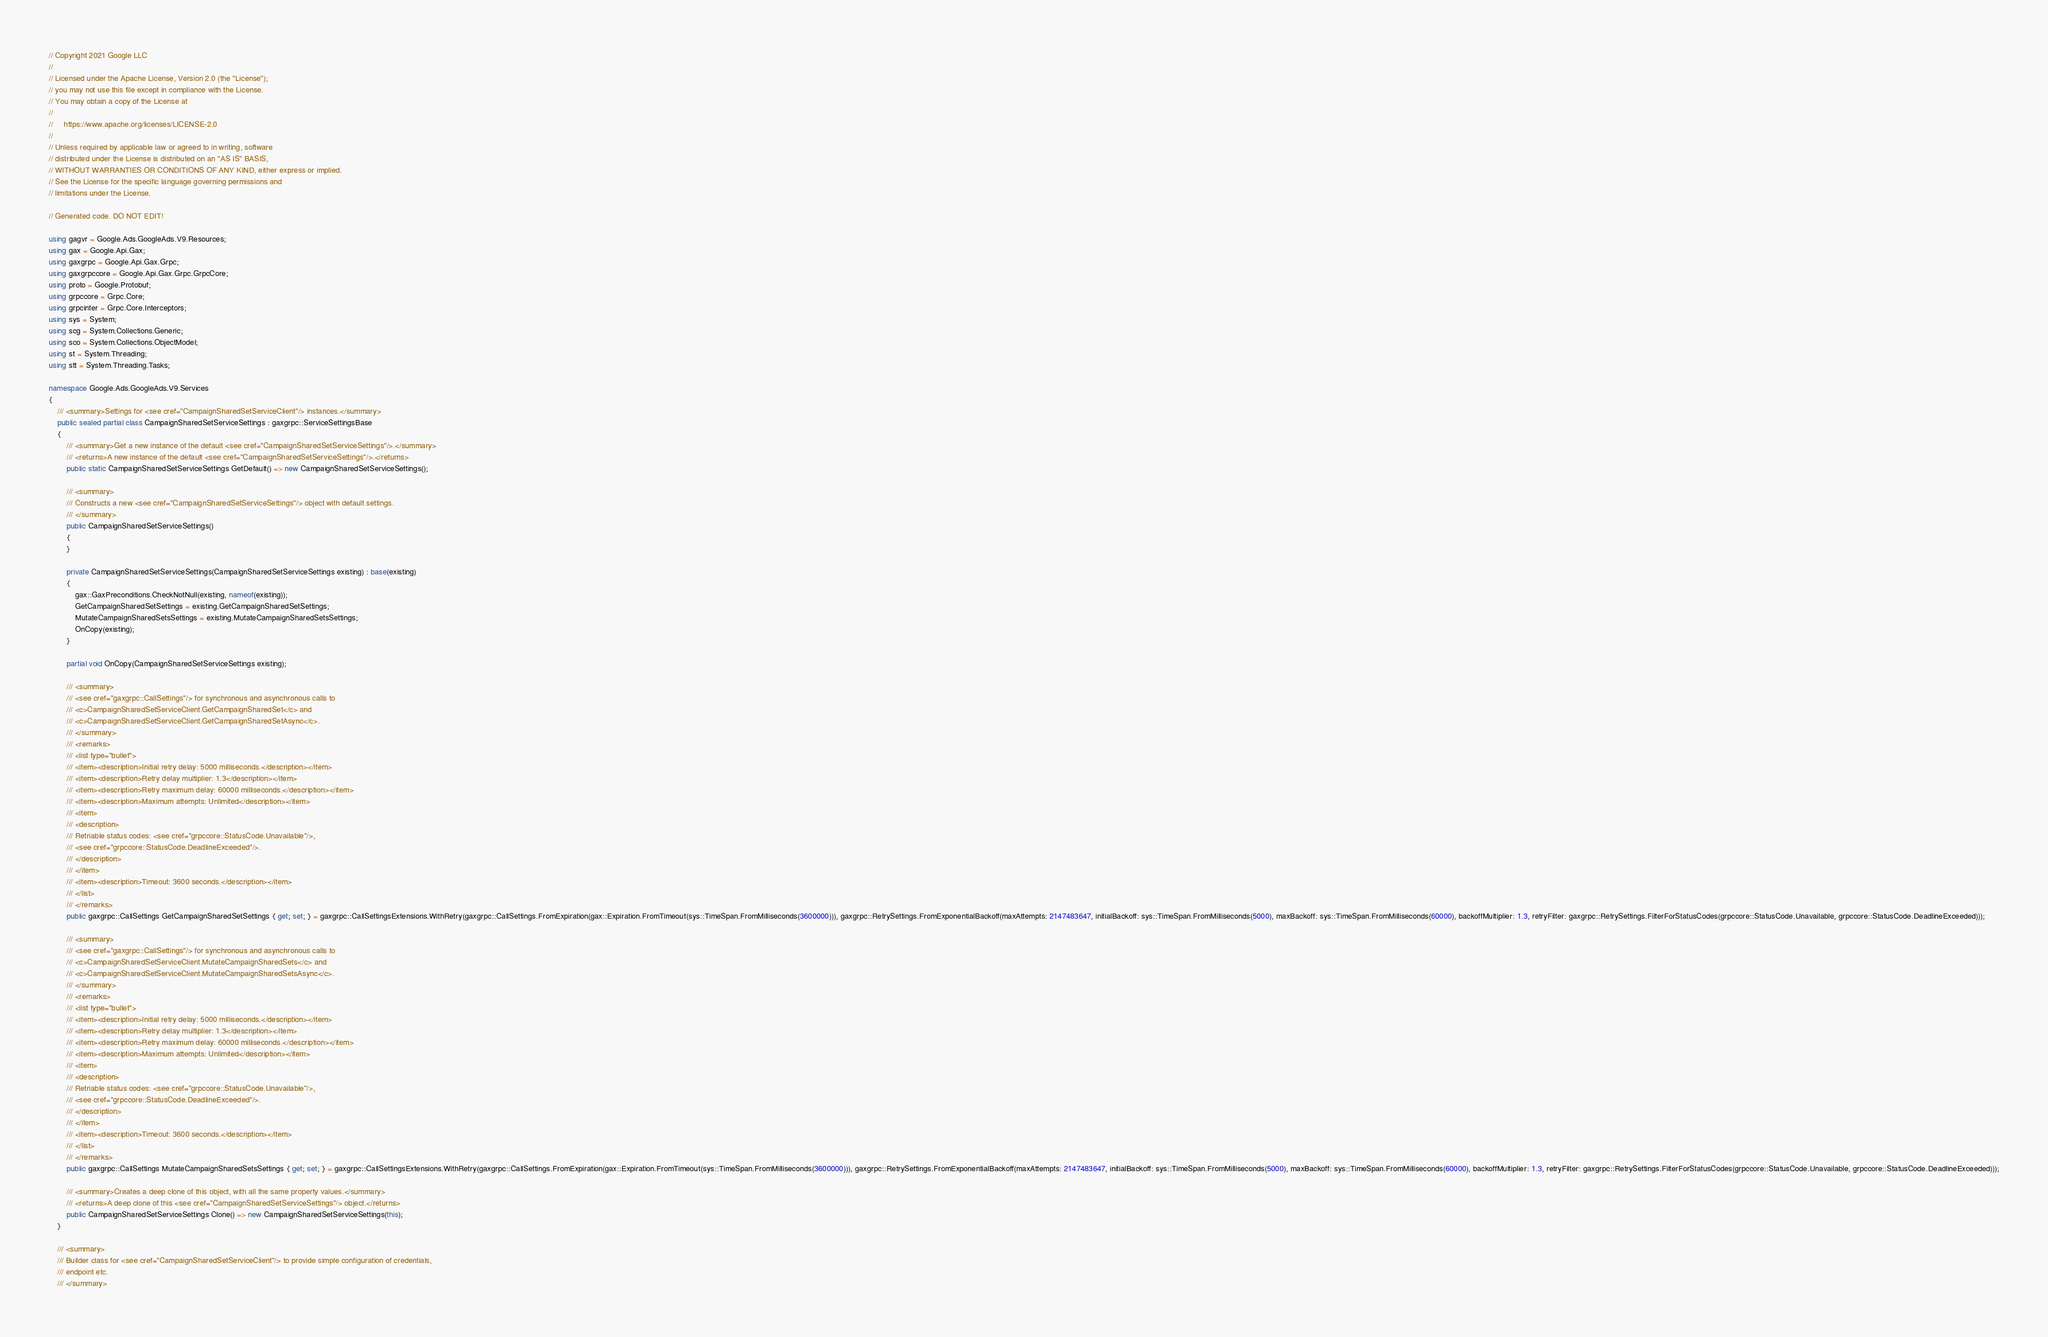Convert code to text. <code><loc_0><loc_0><loc_500><loc_500><_C#_>// Copyright 2021 Google LLC
//
// Licensed under the Apache License, Version 2.0 (the "License");
// you may not use this file except in compliance with the License.
// You may obtain a copy of the License at
//
//     https://www.apache.org/licenses/LICENSE-2.0
//
// Unless required by applicable law or agreed to in writing, software
// distributed under the License is distributed on an "AS IS" BASIS,
// WITHOUT WARRANTIES OR CONDITIONS OF ANY KIND, either express or implied.
// See the License for the specific language governing permissions and
// limitations under the License.

// Generated code. DO NOT EDIT!

using gagvr = Google.Ads.GoogleAds.V9.Resources;
using gax = Google.Api.Gax;
using gaxgrpc = Google.Api.Gax.Grpc;
using gaxgrpccore = Google.Api.Gax.Grpc.GrpcCore;
using proto = Google.Protobuf;
using grpccore = Grpc.Core;
using grpcinter = Grpc.Core.Interceptors;
using sys = System;
using scg = System.Collections.Generic;
using sco = System.Collections.ObjectModel;
using st = System.Threading;
using stt = System.Threading.Tasks;

namespace Google.Ads.GoogleAds.V9.Services
{
    /// <summary>Settings for <see cref="CampaignSharedSetServiceClient"/> instances.</summary>
    public sealed partial class CampaignSharedSetServiceSettings : gaxgrpc::ServiceSettingsBase
    {
        /// <summary>Get a new instance of the default <see cref="CampaignSharedSetServiceSettings"/>.</summary>
        /// <returns>A new instance of the default <see cref="CampaignSharedSetServiceSettings"/>.</returns>
        public static CampaignSharedSetServiceSettings GetDefault() => new CampaignSharedSetServiceSettings();

        /// <summary>
        /// Constructs a new <see cref="CampaignSharedSetServiceSettings"/> object with default settings.
        /// </summary>
        public CampaignSharedSetServiceSettings()
        {
        }

        private CampaignSharedSetServiceSettings(CampaignSharedSetServiceSettings existing) : base(existing)
        {
            gax::GaxPreconditions.CheckNotNull(existing, nameof(existing));
            GetCampaignSharedSetSettings = existing.GetCampaignSharedSetSettings;
            MutateCampaignSharedSetsSettings = existing.MutateCampaignSharedSetsSettings;
            OnCopy(existing);
        }

        partial void OnCopy(CampaignSharedSetServiceSettings existing);

        /// <summary>
        /// <see cref="gaxgrpc::CallSettings"/> for synchronous and asynchronous calls to
        /// <c>CampaignSharedSetServiceClient.GetCampaignSharedSet</c> and
        /// <c>CampaignSharedSetServiceClient.GetCampaignSharedSetAsync</c>.
        /// </summary>
        /// <remarks>
        /// <list type="bullet">
        /// <item><description>Initial retry delay: 5000 milliseconds.</description></item>
        /// <item><description>Retry delay multiplier: 1.3</description></item>
        /// <item><description>Retry maximum delay: 60000 milliseconds.</description></item>
        /// <item><description>Maximum attempts: Unlimited</description></item>
        /// <item>
        /// <description>
        /// Retriable status codes: <see cref="grpccore::StatusCode.Unavailable"/>,
        /// <see cref="grpccore::StatusCode.DeadlineExceeded"/>.
        /// </description>
        /// </item>
        /// <item><description>Timeout: 3600 seconds.</description></item>
        /// </list>
        /// </remarks>
        public gaxgrpc::CallSettings GetCampaignSharedSetSettings { get; set; } = gaxgrpc::CallSettingsExtensions.WithRetry(gaxgrpc::CallSettings.FromExpiration(gax::Expiration.FromTimeout(sys::TimeSpan.FromMilliseconds(3600000))), gaxgrpc::RetrySettings.FromExponentialBackoff(maxAttempts: 2147483647, initialBackoff: sys::TimeSpan.FromMilliseconds(5000), maxBackoff: sys::TimeSpan.FromMilliseconds(60000), backoffMultiplier: 1.3, retryFilter: gaxgrpc::RetrySettings.FilterForStatusCodes(grpccore::StatusCode.Unavailable, grpccore::StatusCode.DeadlineExceeded)));

        /// <summary>
        /// <see cref="gaxgrpc::CallSettings"/> for synchronous and asynchronous calls to
        /// <c>CampaignSharedSetServiceClient.MutateCampaignSharedSets</c> and
        /// <c>CampaignSharedSetServiceClient.MutateCampaignSharedSetsAsync</c>.
        /// </summary>
        /// <remarks>
        /// <list type="bullet">
        /// <item><description>Initial retry delay: 5000 milliseconds.</description></item>
        /// <item><description>Retry delay multiplier: 1.3</description></item>
        /// <item><description>Retry maximum delay: 60000 milliseconds.</description></item>
        /// <item><description>Maximum attempts: Unlimited</description></item>
        /// <item>
        /// <description>
        /// Retriable status codes: <see cref="grpccore::StatusCode.Unavailable"/>,
        /// <see cref="grpccore::StatusCode.DeadlineExceeded"/>.
        /// </description>
        /// </item>
        /// <item><description>Timeout: 3600 seconds.</description></item>
        /// </list>
        /// </remarks>
        public gaxgrpc::CallSettings MutateCampaignSharedSetsSettings { get; set; } = gaxgrpc::CallSettingsExtensions.WithRetry(gaxgrpc::CallSettings.FromExpiration(gax::Expiration.FromTimeout(sys::TimeSpan.FromMilliseconds(3600000))), gaxgrpc::RetrySettings.FromExponentialBackoff(maxAttempts: 2147483647, initialBackoff: sys::TimeSpan.FromMilliseconds(5000), maxBackoff: sys::TimeSpan.FromMilliseconds(60000), backoffMultiplier: 1.3, retryFilter: gaxgrpc::RetrySettings.FilterForStatusCodes(grpccore::StatusCode.Unavailable, grpccore::StatusCode.DeadlineExceeded)));

        /// <summary>Creates a deep clone of this object, with all the same property values.</summary>
        /// <returns>A deep clone of this <see cref="CampaignSharedSetServiceSettings"/> object.</returns>
        public CampaignSharedSetServiceSettings Clone() => new CampaignSharedSetServiceSettings(this);
    }

    /// <summary>
    /// Builder class for <see cref="CampaignSharedSetServiceClient"/> to provide simple configuration of credentials,
    /// endpoint etc.
    /// </summary></code> 